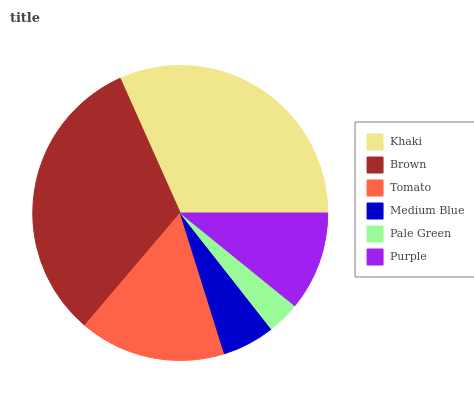Is Pale Green the minimum?
Answer yes or no. Yes. Is Brown the maximum?
Answer yes or no. Yes. Is Tomato the minimum?
Answer yes or no. No. Is Tomato the maximum?
Answer yes or no. No. Is Brown greater than Tomato?
Answer yes or no. Yes. Is Tomato less than Brown?
Answer yes or no. Yes. Is Tomato greater than Brown?
Answer yes or no. No. Is Brown less than Tomato?
Answer yes or no. No. Is Tomato the high median?
Answer yes or no. Yes. Is Purple the low median?
Answer yes or no. Yes. Is Khaki the high median?
Answer yes or no. No. Is Pale Green the low median?
Answer yes or no. No. 